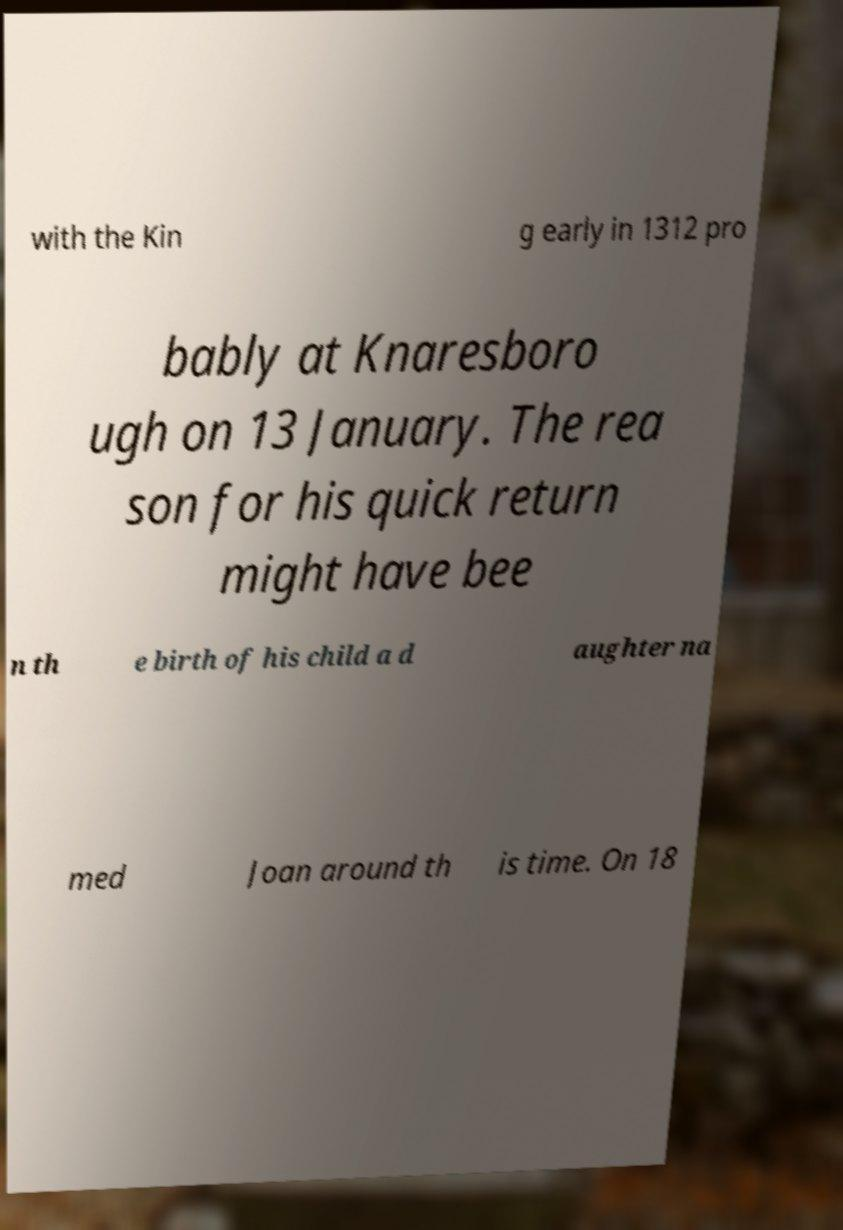I need the written content from this picture converted into text. Can you do that? with the Kin g early in 1312 pro bably at Knaresboro ugh on 13 January. The rea son for his quick return might have bee n th e birth of his child a d aughter na med Joan around th is time. On 18 